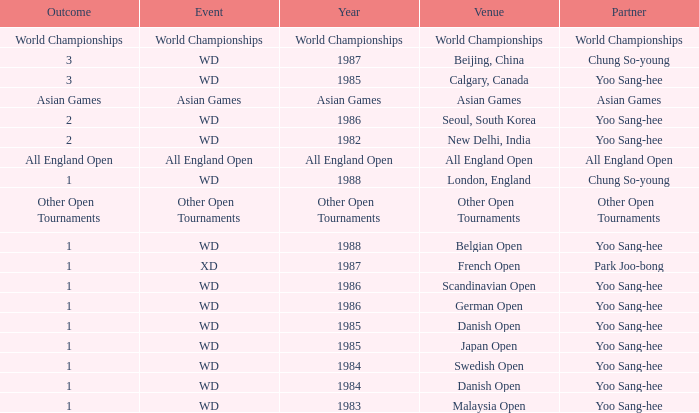What was the location in 1986 with a result of 1? Scandinavian Open, German Open. 